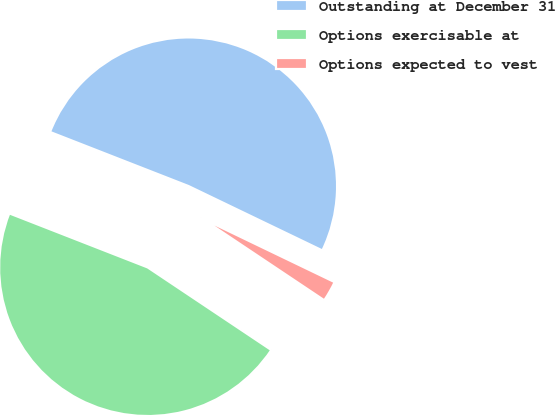<chart> <loc_0><loc_0><loc_500><loc_500><pie_chart><fcel>Outstanding at December 31<fcel>Options exercisable at<fcel>Options expected to vest<nl><fcel>51.21%<fcel>46.55%<fcel>2.24%<nl></chart> 